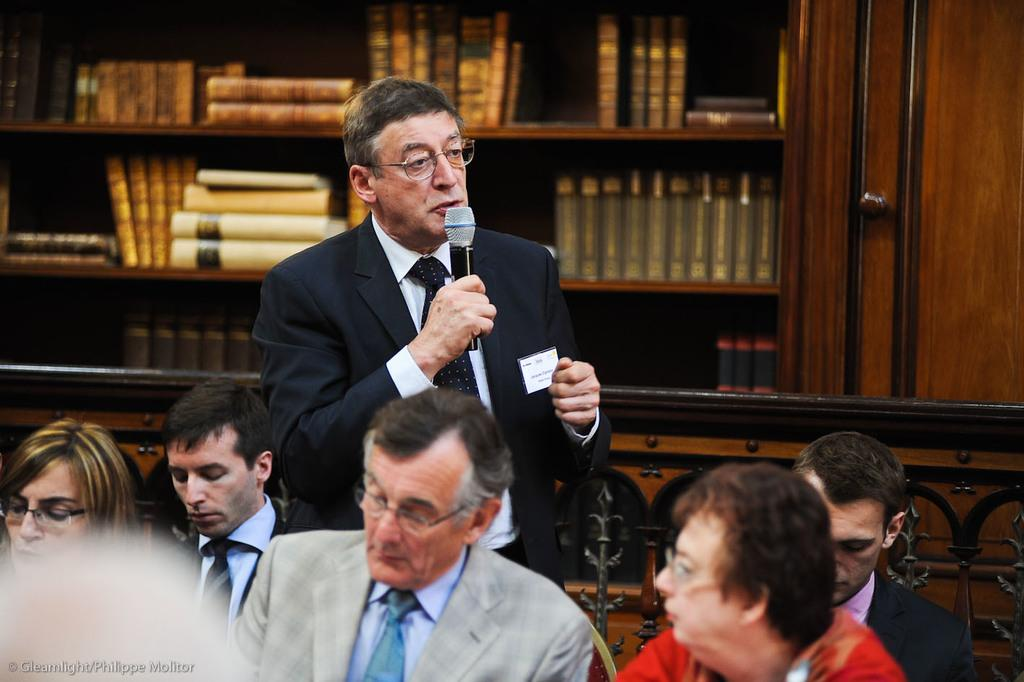What is happening in the image involving the group of people? There is a man talking on a mic while standing in front of a group of people. Can you describe the man's actions in the image? The man is talking on a mic while standing. What can be seen behind the man in the image? There are books in a cupboard behind the man. What type of silver is being cast by the man in the image? There is no silver or casting activity present in the image. What is the man doing with his head in the image? The man is talking on a mic, and there is no specific action involving his head mentioned in the image. 